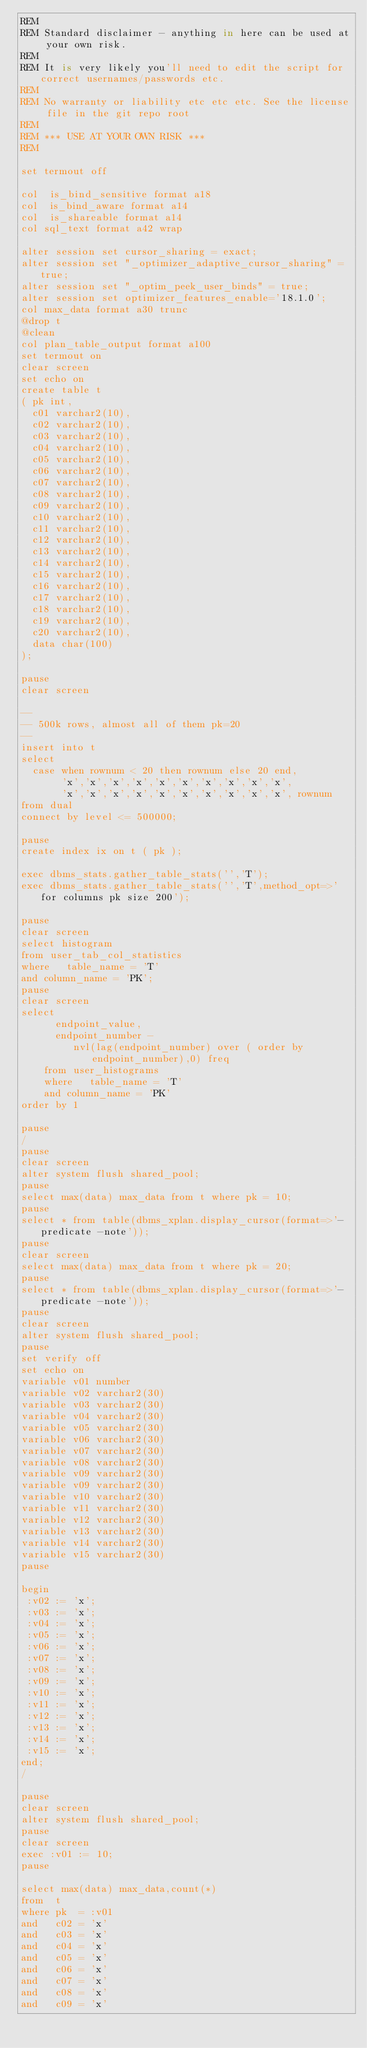Convert code to text. <code><loc_0><loc_0><loc_500><loc_500><_SQL_>REM
REM Standard disclaimer - anything in here can be used at your own risk.
REM 
REM It is very likely you'll need to edit the script for correct usernames/passwords etc.
REM 
REM No warranty or liability etc etc etc. See the license file in the git repo root
REM
REM *** USE AT YOUR OWN RISK ***
REM 

set termout off

col  is_bind_sensitive format a18
col  is_bind_aware format a14
col  is_shareable format a14
col sql_text format a42 wrap

alter session set cursor_sharing = exact;
alter session set "_optimizer_adaptive_cursor_sharing" = true;
alter session set "_optim_peek_user_binds" = true;
alter session set optimizer_features_enable='18.1.0';
col max_data format a30 trunc
@drop t
@clean
col plan_table_output format a100
set termout on
clear screen
set echo on
create table t 
( pk int,
  c01 varchar2(10),
  c02 varchar2(10),
  c03 varchar2(10),
  c04 varchar2(10),
  c05 varchar2(10),
  c06 varchar2(10),
  c07 varchar2(10),
  c08 varchar2(10),
  c09 varchar2(10),
  c10 varchar2(10),
  c11 varchar2(10),
  c12 varchar2(10),
  c13 varchar2(10),
  c14 varchar2(10),
  c15 varchar2(10),
  c16 varchar2(10),
  c17 varchar2(10),
  c18 varchar2(10),
  c19 varchar2(10),
  c20 varchar2(10),
  data char(100)
);

pause
clear screen

--
-- 500k rows, almost all of them pk=20
--
insert into t
select 
  case when rownum < 20 then rownum else 20 end, 
       'x','x','x','x','x','x','x','x','x','x',
       'x','x','x','x','x','x','x','x','x','x', rownum
from dual
connect by level <= 500000;

pause
create index ix on t ( pk );

exec dbms_stats.gather_table_stats('','T');
exec dbms_stats.gather_table_stats('','T',method_opt=>'for columns pk size 200');

pause
clear screen
select histogram 
from user_tab_col_statistics
where   table_name = 'T'
and column_name = 'PK';
pause
clear screen
select
      endpoint_value,
      endpoint_number -
         nvl(lag(endpoint_number) over ( order by endpoint_number),0) freq
    from user_histograms
    where   table_name = 'T'
    and column_name = 'PK'
order by 1

pause
/
pause
clear screen
alter system flush shared_pool;
pause
select max(data) max_data from t where pk = 10;
pause
select * from table(dbms_xplan.display_cursor(format=>'-predicate -note'));
pause
clear screen
select max(data) max_data from t where pk = 20;
pause
select * from table(dbms_xplan.display_cursor(format=>'-predicate -note'));
pause
clear screen
alter system flush shared_pool;
pause
set verify off
set echo on
variable v01 number
variable v02 varchar2(30)
variable v03 varchar2(30)
variable v04 varchar2(30)
variable v05 varchar2(30)
variable v06 varchar2(30)
variable v07 varchar2(30)
variable v08 varchar2(30)
variable v09 varchar2(30)
variable v09 varchar2(30)
variable v10 varchar2(30)
variable v11 varchar2(30)
variable v12 varchar2(30)
variable v13 varchar2(30)
variable v14 varchar2(30)
variable v15 varchar2(30)
pause

begin
 :v02 := 'x';
 :v03 := 'x';
 :v04 := 'x';
 :v05 := 'x';
 :v06 := 'x';
 :v07 := 'x';
 :v08 := 'x';
 :v09 := 'x';
 :v10 := 'x';
 :v11 := 'x';
 :v12 := 'x';
 :v13 := 'x';
 :v14 := 'x';
 :v15 := 'x';
end;
/

pause
clear screen
alter system flush shared_pool;
pause
clear screen
exec :v01 := 10;
pause

select max(data) max_data,count(*) 
from  t 
where pk  = :v01
and   c02 = 'x'
and   c03 = 'x'
and   c04 = 'x'
and   c05 = 'x'
and   c06 = 'x'
and   c07 = 'x'
and   c08 = 'x'
and   c09 = 'x'</code> 